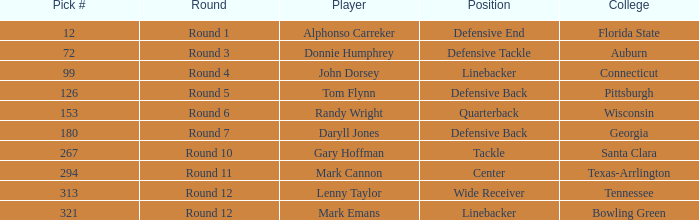What is the Position of Pick #321? Linebacker. 